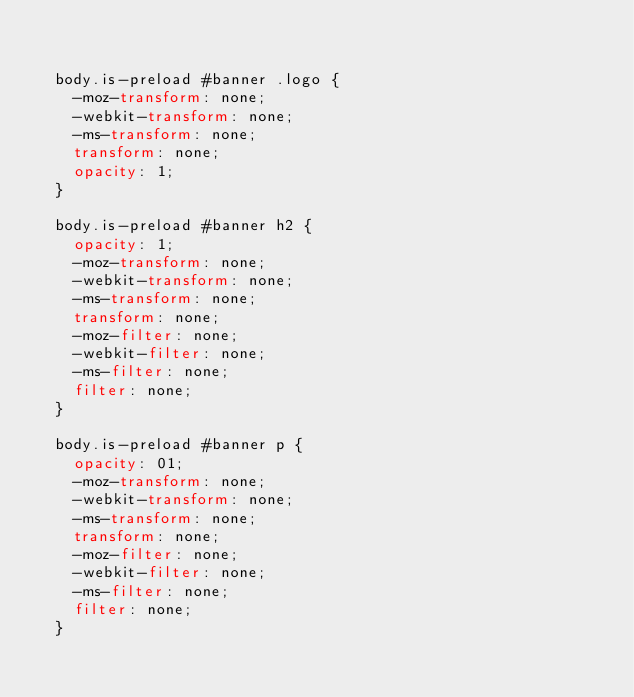<code> <loc_0><loc_0><loc_500><loc_500><_CSS_>

	body.is-preload #banner .logo {
		-moz-transform: none;
		-webkit-transform: none;
		-ms-transform: none;
		transform: none;
		opacity: 1;
	}

	body.is-preload #banner h2 {
		opacity: 1;
		-moz-transform: none;
		-webkit-transform: none;
		-ms-transform: none;
		transform: none;
		-moz-filter: none;
		-webkit-filter: none;
		-ms-filter: none;
		filter: none;
	}

	body.is-preload #banner p {
		opacity: 01;
		-moz-transform: none;
		-webkit-transform: none;
		-ms-transform: none;
		transform: none;
		-moz-filter: none;
		-webkit-filter: none;
		-ms-filter: none;
		filter: none;
	}</code> 